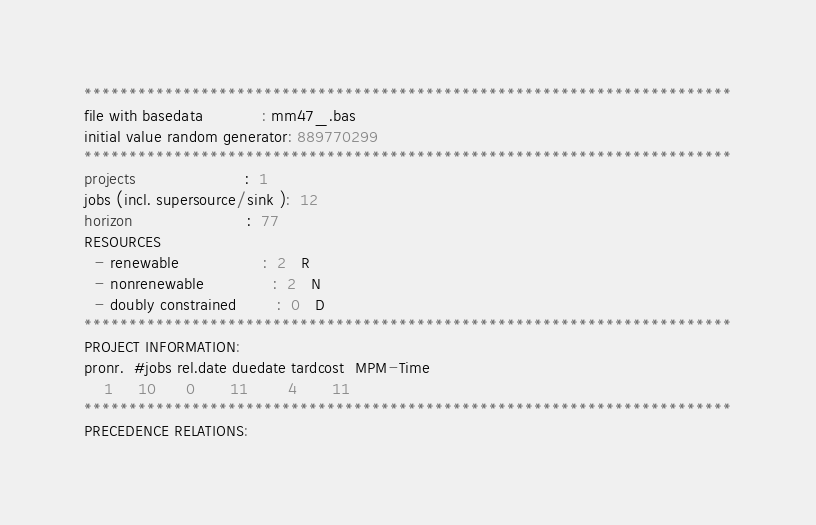Convert code to text. <code><loc_0><loc_0><loc_500><loc_500><_ObjectiveC_>************************************************************************
file with basedata            : mm47_.bas
initial value random generator: 889770299
************************************************************************
projects                      :  1
jobs (incl. supersource/sink ):  12
horizon                       :  77
RESOURCES
  - renewable                 :  2   R
  - nonrenewable              :  2   N
  - doubly constrained        :  0   D
************************************************************************
PROJECT INFORMATION:
pronr.  #jobs rel.date duedate tardcost  MPM-Time
    1     10      0       11        4       11
************************************************************************
PRECEDENCE RELATIONS:</code> 